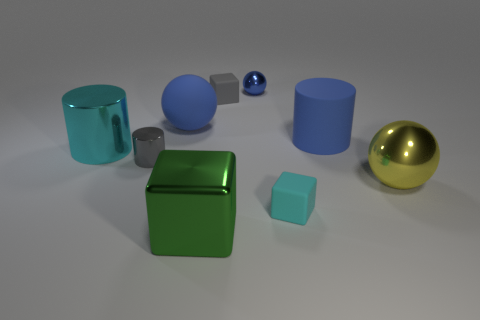Subtract all matte cubes. How many cubes are left? 1 Add 1 big green shiny cylinders. How many objects exist? 10 Subtract all blue spheres. How many spheres are left? 1 Subtract 1 blocks. How many blocks are left? 2 Subtract all gray cubes. How many blue spheres are left? 2 Subtract all small cyan matte blocks. Subtract all gray rubber blocks. How many objects are left? 7 Add 2 cylinders. How many cylinders are left? 5 Add 5 big blocks. How many big blocks exist? 6 Subtract 1 cyan blocks. How many objects are left? 8 Subtract all purple balls. Subtract all yellow cubes. How many balls are left? 3 